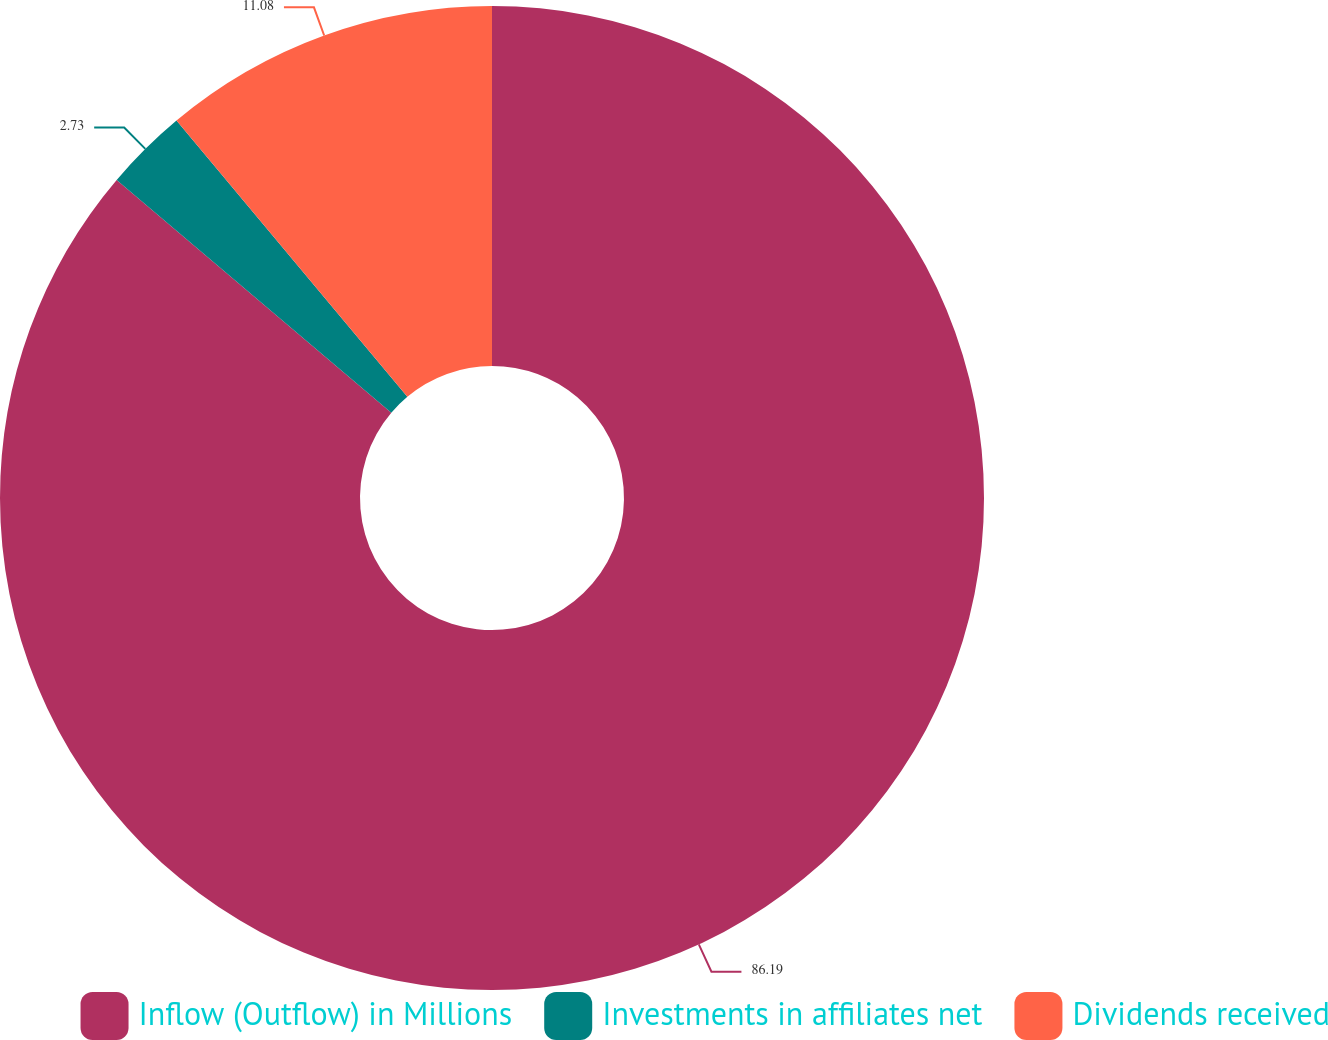Convert chart to OTSL. <chart><loc_0><loc_0><loc_500><loc_500><pie_chart><fcel>Inflow (Outflow) in Millions<fcel>Investments in affiliates net<fcel>Dividends received<nl><fcel>86.19%<fcel>2.73%<fcel>11.08%<nl></chart> 